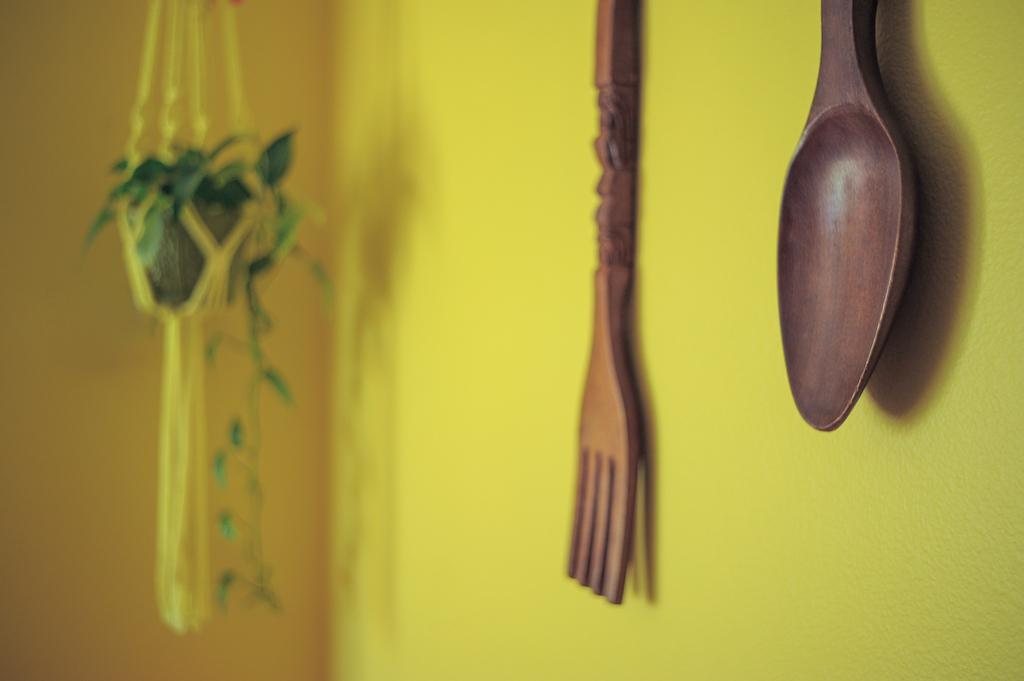What type of utensils are present in the image? There are two wooden spoons in the image. What type of rifle is being used to attempt a shot in the image? There is no rifle or attempt to shoot in the image; it only features two wooden spoons. 